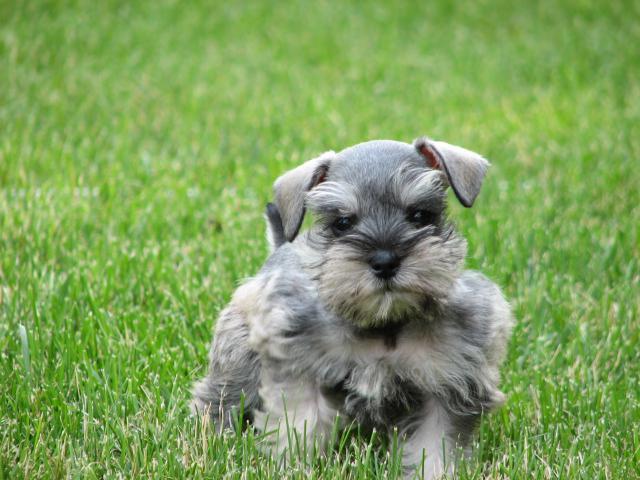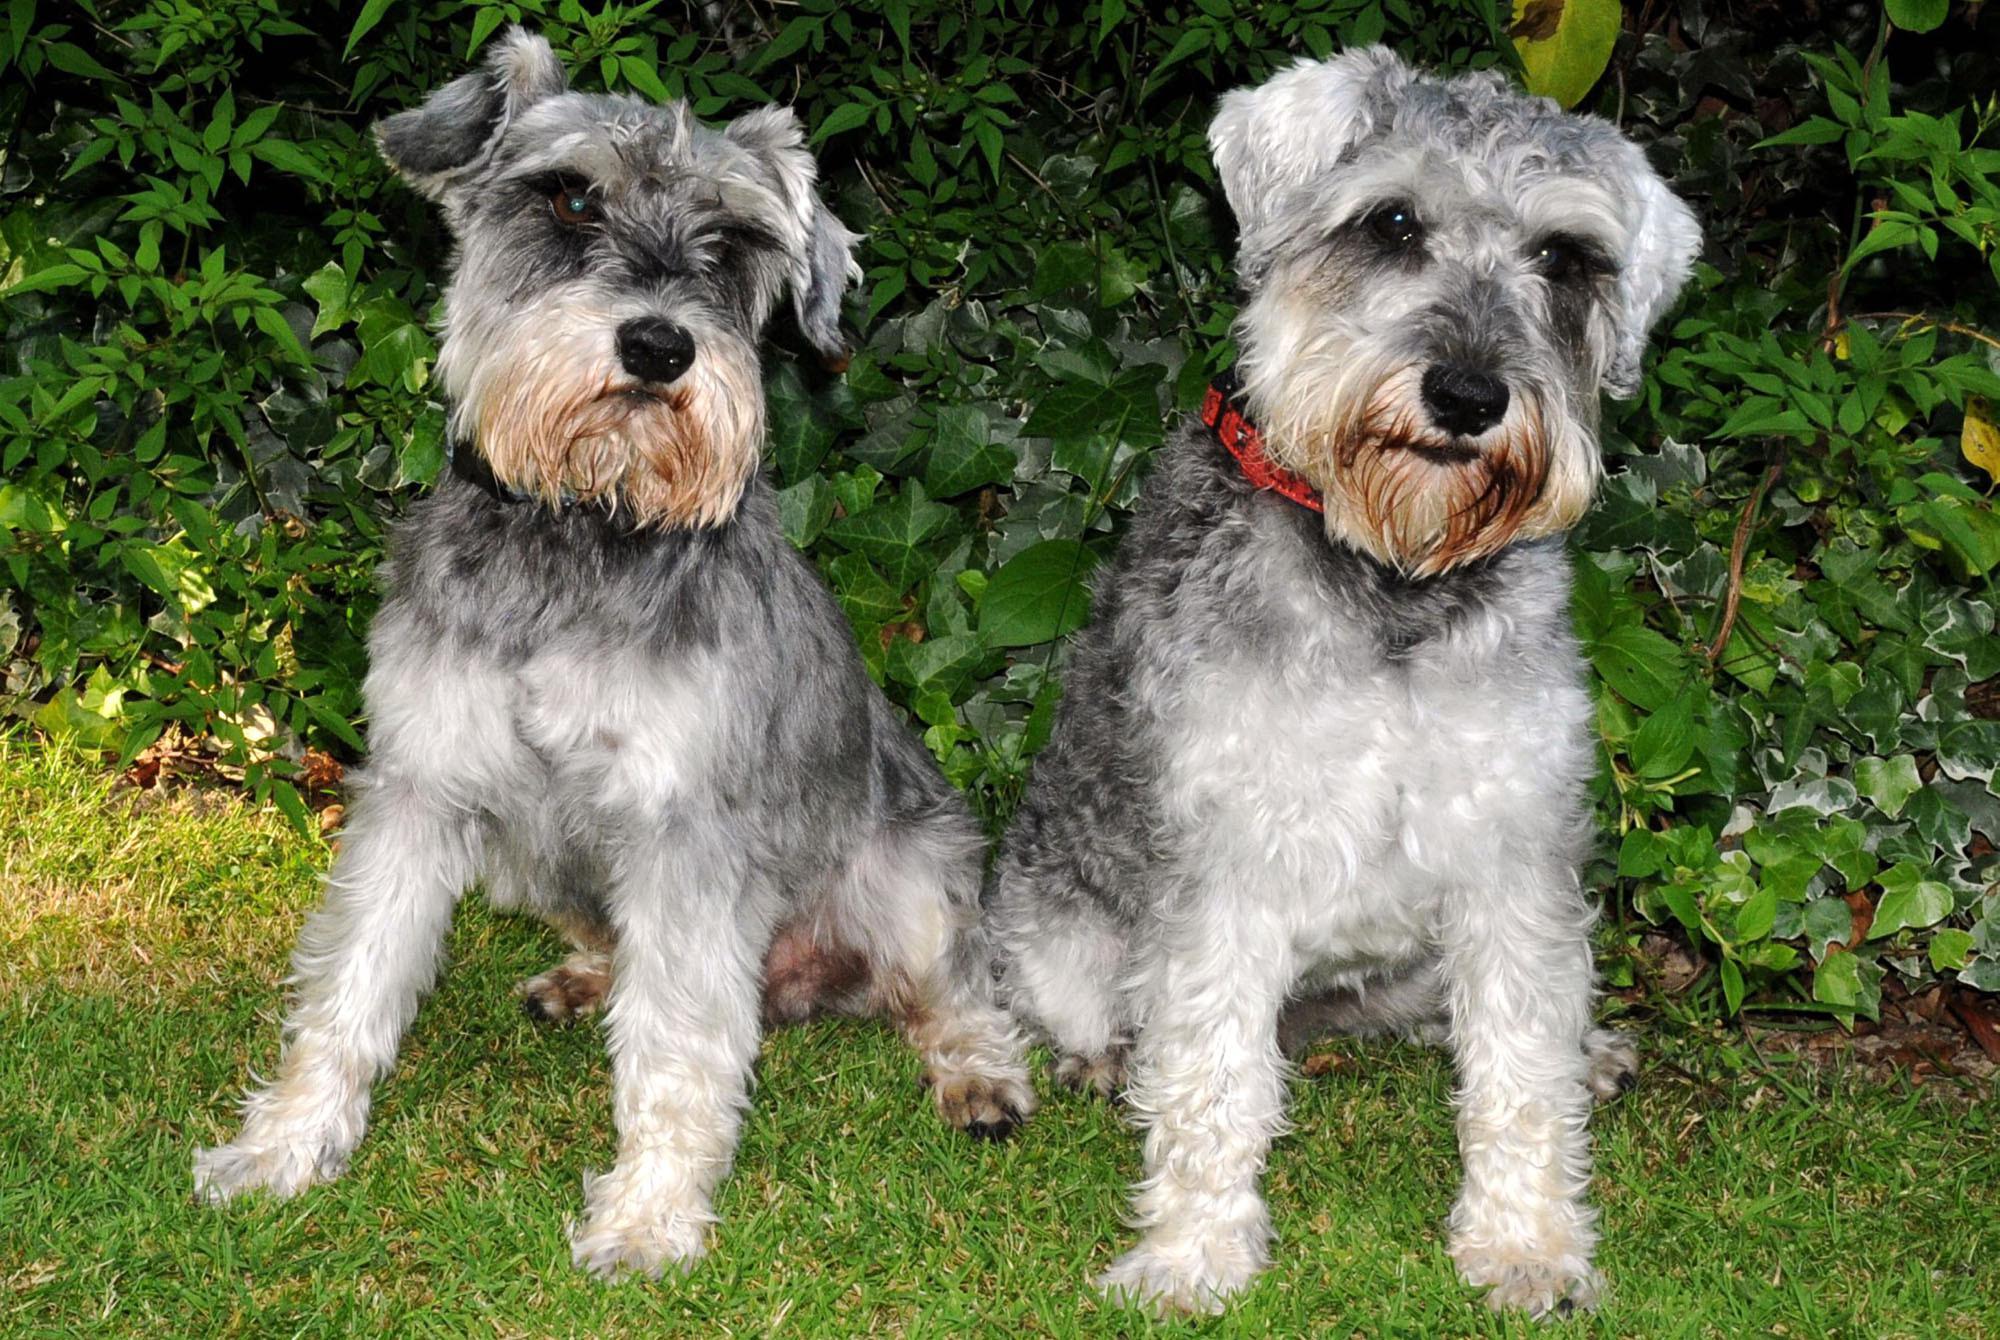The first image is the image on the left, the second image is the image on the right. Given the left and right images, does the statement "The right image contains no more than one dog." hold true? Answer yes or no. No. The first image is the image on the left, the second image is the image on the right. For the images shown, is this caption "There are at most two dogs." true? Answer yes or no. No. 